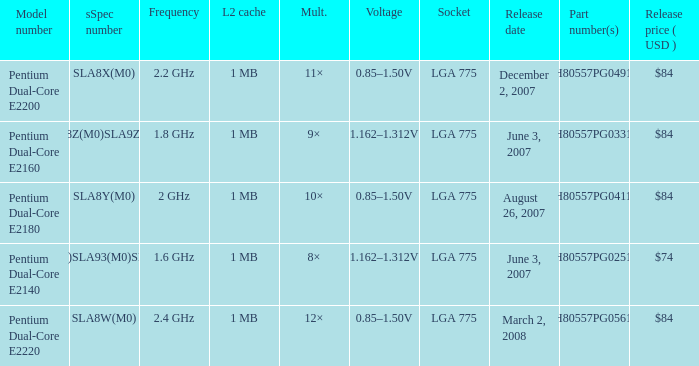What's the voltage for the pentium dual-core e2140? 1.162–1.312V. 